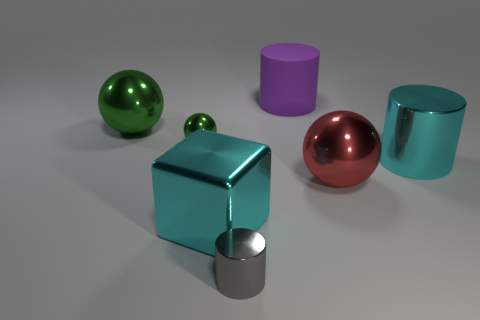There is another ball that is the same color as the small ball; what size is it?
Give a very brief answer. Large. What number of other things are the same size as the purple matte cylinder?
Make the answer very short. 4. What is the shape of the big thing that is in front of the sphere on the right side of the small thing in front of the cube?
Your answer should be very brief. Cube. How many gray objects are either rubber objects or shiny objects?
Provide a succinct answer. 1. How many purple cylinders are behind the cyan cylinder that is on the right side of the small gray metal cylinder?
Your answer should be very brief. 1. Is there anything else of the same color as the large matte cylinder?
Ensure brevity in your answer.  No. The large green thing that is made of the same material as the gray thing is what shape?
Offer a very short reply. Sphere. Do the big shiny cube and the big metallic cylinder have the same color?
Ensure brevity in your answer.  Yes. Does the large cylinder to the right of the large purple cylinder have the same material as the ball on the right side of the small gray cylinder?
Provide a succinct answer. Yes. How many objects are matte cylinders or shiny things that are on the right side of the rubber thing?
Provide a succinct answer. 3. 